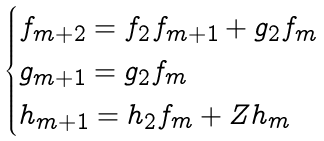Convert formula to latex. <formula><loc_0><loc_0><loc_500><loc_500>\begin{cases} f _ { m + 2 } = f _ { 2 } f _ { m + 1 } + g _ { 2 } f _ { m } \\ g _ { m + 1 } = g _ { 2 } f _ { m } \\ h _ { m + 1 } = h _ { 2 } f _ { m } + Z h _ { m } \end{cases}</formula> 